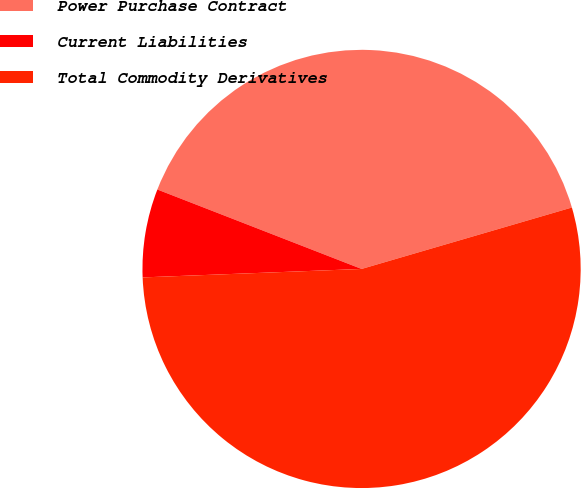<chart> <loc_0><loc_0><loc_500><loc_500><pie_chart><fcel>Power Purchase Contract<fcel>Current Liabilities<fcel>Total Commodity Derivatives<nl><fcel>39.57%<fcel>6.52%<fcel>53.91%<nl></chart> 